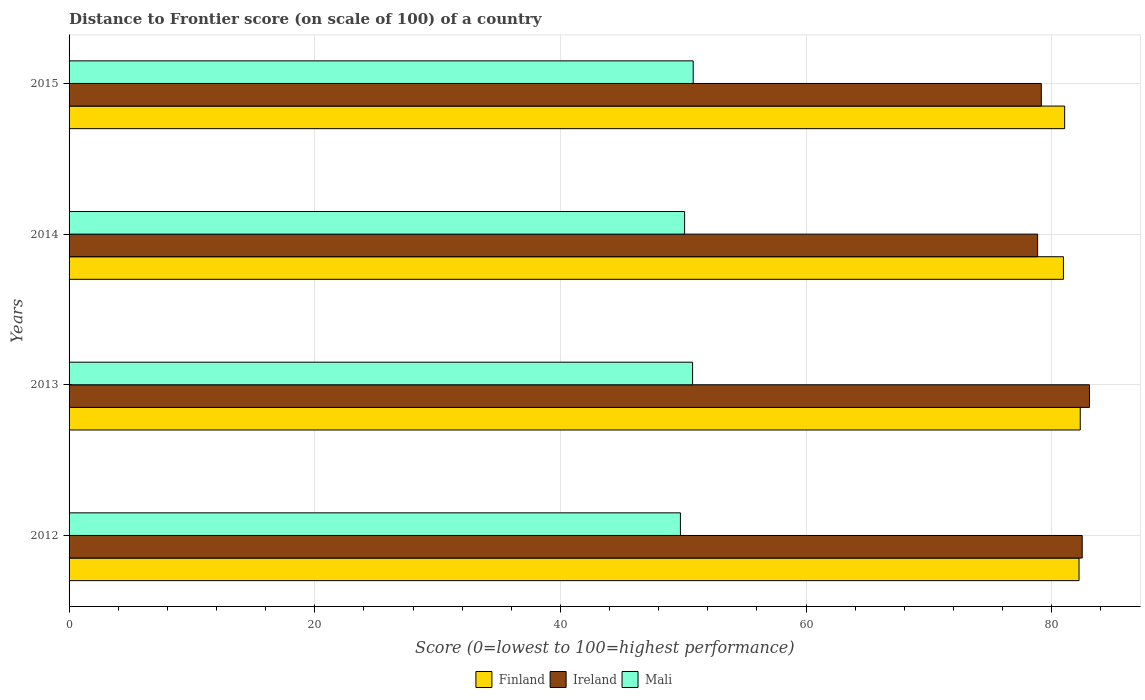How many different coloured bars are there?
Make the answer very short. 3. How many groups of bars are there?
Your answer should be very brief. 4. Are the number of bars per tick equal to the number of legend labels?
Your answer should be very brief. Yes. How many bars are there on the 2nd tick from the top?
Make the answer very short. 3. What is the label of the 4th group of bars from the top?
Your answer should be compact. 2012. What is the distance to frontier score of in Mali in 2014?
Offer a very short reply. 50.11. Across all years, what is the maximum distance to frontier score of in Mali?
Keep it short and to the point. 50.81. Across all years, what is the minimum distance to frontier score of in Ireland?
Your answer should be very brief. 78.85. What is the total distance to frontier score of in Finland in the graph?
Provide a succinct answer. 326.54. What is the difference between the distance to frontier score of in Finland in 2012 and that in 2014?
Keep it short and to the point. 1.27. What is the difference between the distance to frontier score of in Mali in 2014 and the distance to frontier score of in Finland in 2012?
Make the answer very short. -32.11. What is the average distance to frontier score of in Mali per year?
Provide a short and direct response. 50.36. In the year 2015, what is the difference between the distance to frontier score of in Finland and distance to frontier score of in Ireland?
Offer a very short reply. 1.9. What is the ratio of the distance to frontier score of in Finland in 2012 to that in 2013?
Your answer should be very brief. 1. Is the distance to frontier score of in Mali in 2012 less than that in 2014?
Give a very brief answer. Yes. What is the difference between the highest and the second highest distance to frontier score of in Ireland?
Provide a succinct answer. 0.59. What is the difference between the highest and the lowest distance to frontier score of in Finland?
Your response must be concise. 1.37. In how many years, is the distance to frontier score of in Finland greater than the average distance to frontier score of in Finland taken over all years?
Give a very brief answer. 2. What does the 2nd bar from the top in 2013 represents?
Provide a succinct answer. Ireland. What does the 1st bar from the bottom in 2015 represents?
Your response must be concise. Finland. Is it the case that in every year, the sum of the distance to frontier score of in Finland and distance to frontier score of in Ireland is greater than the distance to frontier score of in Mali?
Make the answer very short. Yes. How many years are there in the graph?
Make the answer very short. 4. Does the graph contain any zero values?
Offer a terse response. No. Where does the legend appear in the graph?
Ensure brevity in your answer.  Bottom center. What is the title of the graph?
Make the answer very short. Distance to Frontier score (on scale of 100) of a country. Does "Paraguay" appear as one of the legend labels in the graph?
Keep it short and to the point. No. What is the label or title of the X-axis?
Provide a short and direct response. Score (0=lowest to 100=highest performance). What is the Score (0=lowest to 100=highest performance) of Finland in 2012?
Your response must be concise. 82.22. What is the Score (0=lowest to 100=highest performance) of Ireland in 2012?
Provide a short and direct response. 82.48. What is the Score (0=lowest to 100=highest performance) of Mali in 2012?
Your answer should be very brief. 49.77. What is the Score (0=lowest to 100=highest performance) of Finland in 2013?
Give a very brief answer. 82.32. What is the Score (0=lowest to 100=highest performance) of Ireland in 2013?
Your answer should be compact. 83.07. What is the Score (0=lowest to 100=highest performance) in Mali in 2013?
Your answer should be very brief. 50.76. What is the Score (0=lowest to 100=highest performance) in Finland in 2014?
Give a very brief answer. 80.95. What is the Score (0=lowest to 100=highest performance) in Ireland in 2014?
Provide a succinct answer. 78.85. What is the Score (0=lowest to 100=highest performance) in Mali in 2014?
Ensure brevity in your answer.  50.11. What is the Score (0=lowest to 100=highest performance) of Finland in 2015?
Offer a terse response. 81.05. What is the Score (0=lowest to 100=highest performance) in Ireland in 2015?
Keep it short and to the point. 79.15. What is the Score (0=lowest to 100=highest performance) in Mali in 2015?
Offer a very short reply. 50.81. Across all years, what is the maximum Score (0=lowest to 100=highest performance) of Finland?
Offer a terse response. 82.32. Across all years, what is the maximum Score (0=lowest to 100=highest performance) in Ireland?
Provide a short and direct response. 83.07. Across all years, what is the maximum Score (0=lowest to 100=highest performance) of Mali?
Your answer should be very brief. 50.81. Across all years, what is the minimum Score (0=lowest to 100=highest performance) in Finland?
Make the answer very short. 80.95. Across all years, what is the minimum Score (0=lowest to 100=highest performance) in Ireland?
Provide a succinct answer. 78.85. Across all years, what is the minimum Score (0=lowest to 100=highest performance) of Mali?
Keep it short and to the point. 49.77. What is the total Score (0=lowest to 100=highest performance) in Finland in the graph?
Keep it short and to the point. 326.54. What is the total Score (0=lowest to 100=highest performance) in Ireland in the graph?
Offer a terse response. 323.55. What is the total Score (0=lowest to 100=highest performance) in Mali in the graph?
Provide a succinct answer. 201.45. What is the difference between the Score (0=lowest to 100=highest performance) in Ireland in 2012 and that in 2013?
Your answer should be very brief. -0.59. What is the difference between the Score (0=lowest to 100=highest performance) of Mali in 2012 and that in 2013?
Your answer should be compact. -0.99. What is the difference between the Score (0=lowest to 100=highest performance) in Finland in 2012 and that in 2014?
Ensure brevity in your answer.  1.27. What is the difference between the Score (0=lowest to 100=highest performance) of Ireland in 2012 and that in 2014?
Offer a very short reply. 3.63. What is the difference between the Score (0=lowest to 100=highest performance) of Mali in 2012 and that in 2014?
Provide a succinct answer. -0.34. What is the difference between the Score (0=lowest to 100=highest performance) in Finland in 2012 and that in 2015?
Your answer should be very brief. 1.17. What is the difference between the Score (0=lowest to 100=highest performance) of Ireland in 2012 and that in 2015?
Offer a terse response. 3.33. What is the difference between the Score (0=lowest to 100=highest performance) in Mali in 2012 and that in 2015?
Make the answer very short. -1.04. What is the difference between the Score (0=lowest to 100=highest performance) of Finland in 2013 and that in 2014?
Your response must be concise. 1.37. What is the difference between the Score (0=lowest to 100=highest performance) in Ireland in 2013 and that in 2014?
Provide a short and direct response. 4.22. What is the difference between the Score (0=lowest to 100=highest performance) in Mali in 2013 and that in 2014?
Provide a short and direct response. 0.65. What is the difference between the Score (0=lowest to 100=highest performance) in Finland in 2013 and that in 2015?
Give a very brief answer. 1.27. What is the difference between the Score (0=lowest to 100=highest performance) of Ireland in 2013 and that in 2015?
Your answer should be compact. 3.92. What is the difference between the Score (0=lowest to 100=highest performance) in Mali in 2013 and that in 2015?
Offer a very short reply. -0.05. What is the difference between the Score (0=lowest to 100=highest performance) of Finland in 2012 and the Score (0=lowest to 100=highest performance) of Ireland in 2013?
Make the answer very short. -0.85. What is the difference between the Score (0=lowest to 100=highest performance) of Finland in 2012 and the Score (0=lowest to 100=highest performance) of Mali in 2013?
Offer a terse response. 31.46. What is the difference between the Score (0=lowest to 100=highest performance) in Ireland in 2012 and the Score (0=lowest to 100=highest performance) in Mali in 2013?
Provide a short and direct response. 31.72. What is the difference between the Score (0=lowest to 100=highest performance) of Finland in 2012 and the Score (0=lowest to 100=highest performance) of Ireland in 2014?
Your response must be concise. 3.37. What is the difference between the Score (0=lowest to 100=highest performance) of Finland in 2012 and the Score (0=lowest to 100=highest performance) of Mali in 2014?
Your response must be concise. 32.11. What is the difference between the Score (0=lowest to 100=highest performance) in Ireland in 2012 and the Score (0=lowest to 100=highest performance) in Mali in 2014?
Give a very brief answer. 32.37. What is the difference between the Score (0=lowest to 100=highest performance) of Finland in 2012 and the Score (0=lowest to 100=highest performance) of Ireland in 2015?
Make the answer very short. 3.07. What is the difference between the Score (0=lowest to 100=highest performance) in Finland in 2012 and the Score (0=lowest to 100=highest performance) in Mali in 2015?
Offer a very short reply. 31.41. What is the difference between the Score (0=lowest to 100=highest performance) in Ireland in 2012 and the Score (0=lowest to 100=highest performance) in Mali in 2015?
Your response must be concise. 31.67. What is the difference between the Score (0=lowest to 100=highest performance) in Finland in 2013 and the Score (0=lowest to 100=highest performance) in Ireland in 2014?
Keep it short and to the point. 3.47. What is the difference between the Score (0=lowest to 100=highest performance) of Finland in 2013 and the Score (0=lowest to 100=highest performance) of Mali in 2014?
Offer a terse response. 32.21. What is the difference between the Score (0=lowest to 100=highest performance) of Ireland in 2013 and the Score (0=lowest to 100=highest performance) of Mali in 2014?
Ensure brevity in your answer.  32.96. What is the difference between the Score (0=lowest to 100=highest performance) of Finland in 2013 and the Score (0=lowest to 100=highest performance) of Ireland in 2015?
Your answer should be compact. 3.17. What is the difference between the Score (0=lowest to 100=highest performance) of Finland in 2013 and the Score (0=lowest to 100=highest performance) of Mali in 2015?
Provide a short and direct response. 31.51. What is the difference between the Score (0=lowest to 100=highest performance) of Ireland in 2013 and the Score (0=lowest to 100=highest performance) of Mali in 2015?
Provide a succinct answer. 32.26. What is the difference between the Score (0=lowest to 100=highest performance) of Finland in 2014 and the Score (0=lowest to 100=highest performance) of Ireland in 2015?
Provide a succinct answer. 1.8. What is the difference between the Score (0=lowest to 100=highest performance) of Finland in 2014 and the Score (0=lowest to 100=highest performance) of Mali in 2015?
Provide a short and direct response. 30.14. What is the difference between the Score (0=lowest to 100=highest performance) of Ireland in 2014 and the Score (0=lowest to 100=highest performance) of Mali in 2015?
Make the answer very short. 28.04. What is the average Score (0=lowest to 100=highest performance) in Finland per year?
Offer a terse response. 81.64. What is the average Score (0=lowest to 100=highest performance) in Ireland per year?
Give a very brief answer. 80.89. What is the average Score (0=lowest to 100=highest performance) in Mali per year?
Give a very brief answer. 50.36. In the year 2012, what is the difference between the Score (0=lowest to 100=highest performance) in Finland and Score (0=lowest to 100=highest performance) in Ireland?
Provide a succinct answer. -0.26. In the year 2012, what is the difference between the Score (0=lowest to 100=highest performance) of Finland and Score (0=lowest to 100=highest performance) of Mali?
Provide a short and direct response. 32.45. In the year 2012, what is the difference between the Score (0=lowest to 100=highest performance) of Ireland and Score (0=lowest to 100=highest performance) of Mali?
Keep it short and to the point. 32.71. In the year 2013, what is the difference between the Score (0=lowest to 100=highest performance) of Finland and Score (0=lowest to 100=highest performance) of Ireland?
Offer a terse response. -0.75. In the year 2013, what is the difference between the Score (0=lowest to 100=highest performance) of Finland and Score (0=lowest to 100=highest performance) of Mali?
Your response must be concise. 31.56. In the year 2013, what is the difference between the Score (0=lowest to 100=highest performance) of Ireland and Score (0=lowest to 100=highest performance) of Mali?
Provide a succinct answer. 32.31. In the year 2014, what is the difference between the Score (0=lowest to 100=highest performance) in Finland and Score (0=lowest to 100=highest performance) in Ireland?
Your response must be concise. 2.1. In the year 2014, what is the difference between the Score (0=lowest to 100=highest performance) in Finland and Score (0=lowest to 100=highest performance) in Mali?
Your response must be concise. 30.84. In the year 2014, what is the difference between the Score (0=lowest to 100=highest performance) in Ireland and Score (0=lowest to 100=highest performance) in Mali?
Your answer should be compact. 28.74. In the year 2015, what is the difference between the Score (0=lowest to 100=highest performance) in Finland and Score (0=lowest to 100=highest performance) in Mali?
Your response must be concise. 30.24. In the year 2015, what is the difference between the Score (0=lowest to 100=highest performance) of Ireland and Score (0=lowest to 100=highest performance) of Mali?
Ensure brevity in your answer.  28.34. What is the ratio of the Score (0=lowest to 100=highest performance) in Finland in 2012 to that in 2013?
Your answer should be very brief. 1. What is the ratio of the Score (0=lowest to 100=highest performance) of Ireland in 2012 to that in 2013?
Your response must be concise. 0.99. What is the ratio of the Score (0=lowest to 100=highest performance) of Mali in 2012 to that in 2013?
Ensure brevity in your answer.  0.98. What is the ratio of the Score (0=lowest to 100=highest performance) of Finland in 2012 to that in 2014?
Offer a very short reply. 1.02. What is the ratio of the Score (0=lowest to 100=highest performance) in Ireland in 2012 to that in 2014?
Provide a short and direct response. 1.05. What is the ratio of the Score (0=lowest to 100=highest performance) of Mali in 2012 to that in 2014?
Keep it short and to the point. 0.99. What is the ratio of the Score (0=lowest to 100=highest performance) of Finland in 2012 to that in 2015?
Give a very brief answer. 1.01. What is the ratio of the Score (0=lowest to 100=highest performance) in Ireland in 2012 to that in 2015?
Offer a very short reply. 1.04. What is the ratio of the Score (0=lowest to 100=highest performance) of Mali in 2012 to that in 2015?
Your answer should be compact. 0.98. What is the ratio of the Score (0=lowest to 100=highest performance) of Finland in 2013 to that in 2014?
Provide a succinct answer. 1.02. What is the ratio of the Score (0=lowest to 100=highest performance) in Ireland in 2013 to that in 2014?
Provide a short and direct response. 1.05. What is the ratio of the Score (0=lowest to 100=highest performance) of Mali in 2013 to that in 2014?
Offer a terse response. 1.01. What is the ratio of the Score (0=lowest to 100=highest performance) in Finland in 2013 to that in 2015?
Offer a very short reply. 1.02. What is the ratio of the Score (0=lowest to 100=highest performance) in Ireland in 2013 to that in 2015?
Keep it short and to the point. 1.05. What is the ratio of the Score (0=lowest to 100=highest performance) in Mali in 2013 to that in 2015?
Provide a succinct answer. 1. What is the ratio of the Score (0=lowest to 100=highest performance) of Ireland in 2014 to that in 2015?
Provide a succinct answer. 1. What is the ratio of the Score (0=lowest to 100=highest performance) of Mali in 2014 to that in 2015?
Provide a short and direct response. 0.99. What is the difference between the highest and the second highest Score (0=lowest to 100=highest performance) in Finland?
Keep it short and to the point. 0.1. What is the difference between the highest and the second highest Score (0=lowest to 100=highest performance) in Ireland?
Your answer should be compact. 0.59. What is the difference between the highest and the second highest Score (0=lowest to 100=highest performance) of Mali?
Your answer should be compact. 0.05. What is the difference between the highest and the lowest Score (0=lowest to 100=highest performance) of Finland?
Offer a very short reply. 1.37. What is the difference between the highest and the lowest Score (0=lowest to 100=highest performance) of Ireland?
Ensure brevity in your answer.  4.22. 